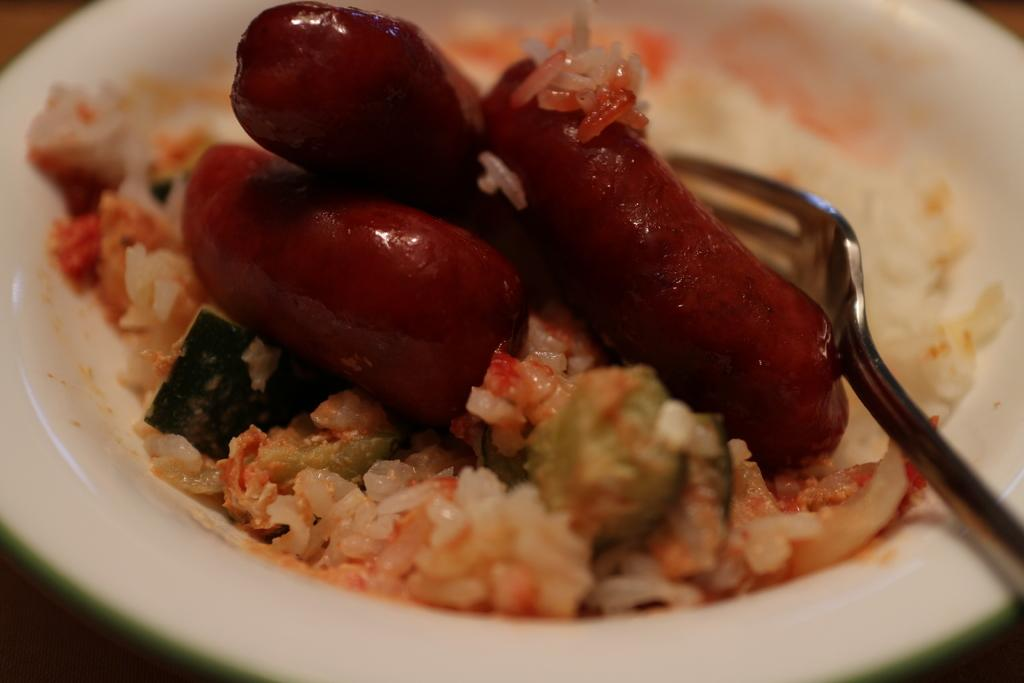What is in the bowl that is visible in the image? There is a bowl with food in the image. Can you describe the colors of the food in the bowl? The food has brown, white, green, and orange colors. What utensil is visible in the image? There is a fork visible in the image. What type of land can be seen in the background of the image? There is no land visible in the image; it only shows a bowl with food and a fork. 